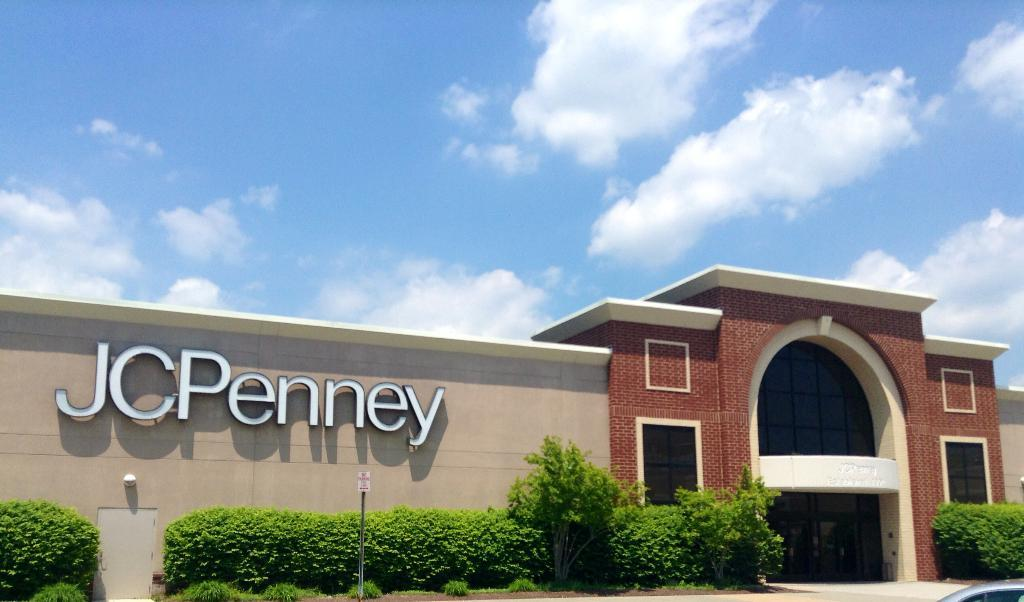What type of structures can be seen in the image? There are buildings in the image. What is located at the bottom of the image? There are plants, trees, and a sign board at the bottom of the image. Can you describe the entrance in the image? There is a door near a plant in the image. What is visible at the top of the image? The sky is visible at the top of the image, and there are clouds visible in the sky. What type of trousers can be seen hanging on the door in the image? There are no trousers visible in the image; the focus is on the buildings, plants, trees, sign board, door, and sky. What type of wine is being served at the bottom of the image? There is no wine present in the image; the focus is on the plants, trees, and sign board at the bottom of the image. 